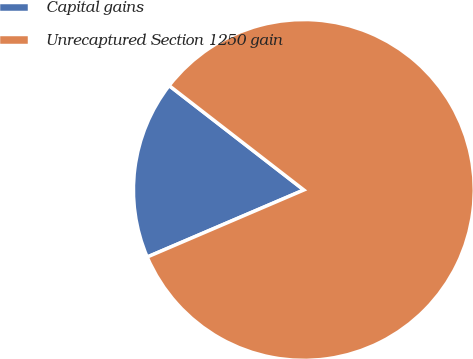Convert chart to OTSL. <chart><loc_0><loc_0><loc_500><loc_500><pie_chart><fcel>Capital gains<fcel>Unrecaptured Section 1250 gain<nl><fcel>16.93%<fcel>83.07%<nl></chart> 